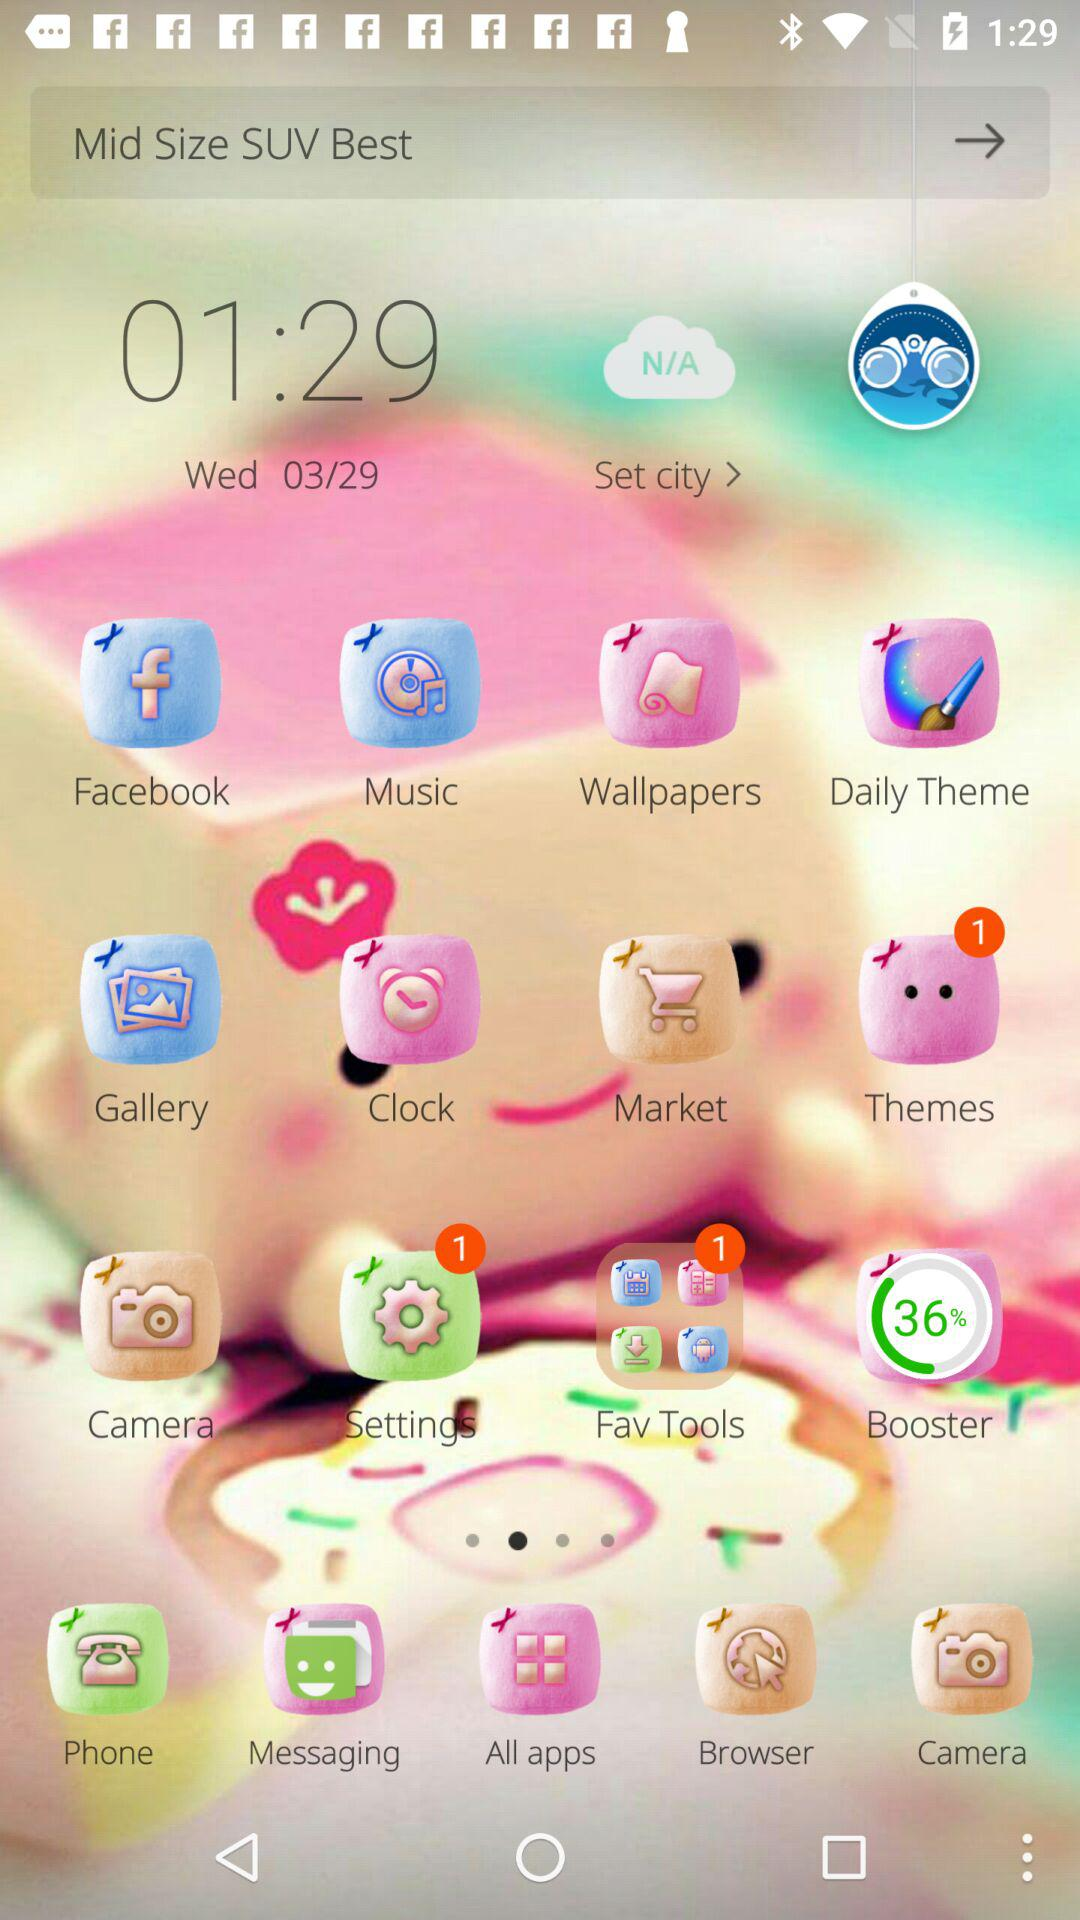What is the given date? The given date is Wednesday, March 29. 